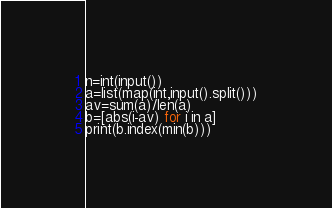Convert code to text. <code><loc_0><loc_0><loc_500><loc_500><_Python_>n=int(input())
a=list(map(int,input().split()))
av=sum(a)/len(a)
b=[abs(i-av) for i in a]
print(b.index(min(b)))</code> 